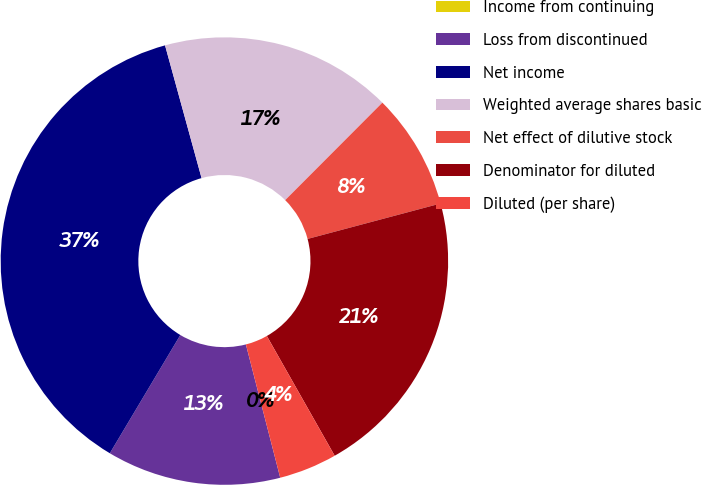Convert chart to OTSL. <chart><loc_0><loc_0><loc_500><loc_500><pie_chart><fcel>Income from continuing<fcel>Loss from discontinued<fcel>Net income<fcel>Weighted average shares basic<fcel>Net effect of dilutive stock<fcel>Denominator for diluted<fcel>Diluted (per share)<nl><fcel>0.0%<fcel>12.57%<fcel>37.17%<fcel>16.75%<fcel>8.38%<fcel>20.94%<fcel>4.19%<nl></chart> 